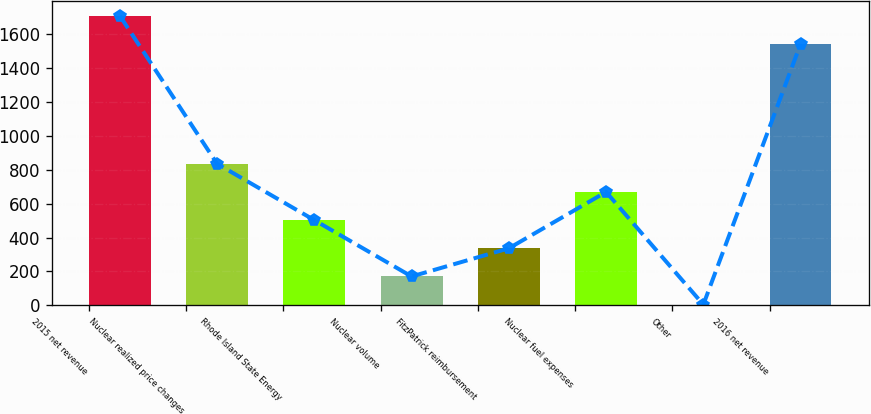Convert chart. <chart><loc_0><loc_0><loc_500><loc_500><bar_chart><fcel>2015 net revenue<fcel>Nuclear realized price changes<fcel>Rhode Island State Energy<fcel>Nuclear volume<fcel>FitzPatrick reimbursement<fcel>Nuclear fuel expenses<fcel>Other<fcel>2016 net revenue<nl><fcel>1708.2<fcel>835<fcel>502.6<fcel>170.2<fcel>336.4<fcel>668.8<fcel>4<fcel>1542<nl></chart> 